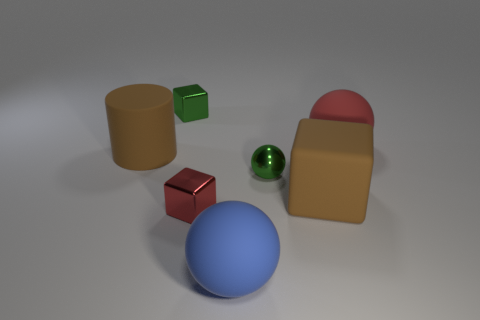Subtract all brown rubber blocks. How many blocks are left? 2 Subtract all blue spheres. How many spheres are left? 2 Subtract all cylinders. How many objects are left? 6 Subtract all tiny green spheres. Subtract all balls. How many objects are left? 3 Add 1 large brown rubber cubes. How many large brown rubber cubes are left? 2 Add 7 big rubber cylinders. How many big rubber cylinders exist? 8 Add 2 tiny green metal balls. How many objects exist? 9 Subtract 1 green cubes. How many objects are left? 6 Subtract 2 spheres. How many spheres are left? 1 Subtract all yellow blocks. Subtract all blue balls. How many blocks are left? 3 